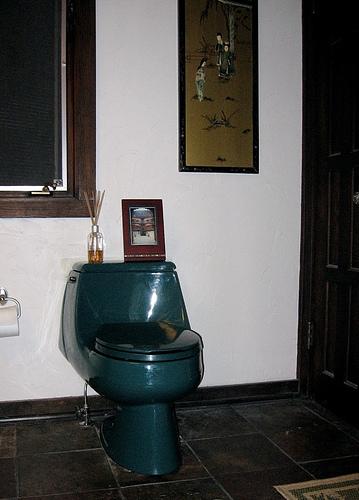What is the color of the toilet seat?
Be succinct. Teal. Is the toilet seat up or down?
Quick response, please. Down. How many pictures can you see?
Short answer required. 2. How dilapidated is this bathroom?
Short answer required. Slightly. What color is the bowl?
Answer briefly. Blue. What color is the toilet?
Short answer required. Green. Is it important to keep this object clean?
Keep it brief. Yes. What type of material is the floor?
Short answer required. Tile. 